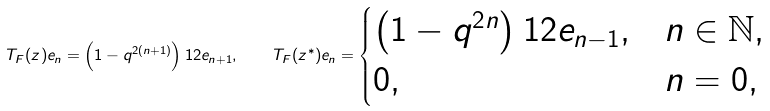<formula> <loc_0><loc_0><loc_500><loc_500>T _ { F } ( z ) e _ { n } = \left ( 1 - q ^ { 2 ( n + 1 ) } \right ) ^ { } { 1 } 2 e _ { n + 1 } , \quad T _ { F } ( z ^ { * } ) e _ { n } = \begin{cases} \left ( 1 - q ^ { 2 n } \right ) ^ { } { 1 } 2 e _ { n - 1 } , & n \in \mathbb { N } , \\ 0 , & n = 0 , \end{cases}</formula> 